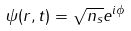Convert formula to latex. <formula><loc_0><loc_0><loc_500><loc_500>\psi ( r , t ) = \sqrt { n _ { s } } e ^ { i \phi }</formula> 